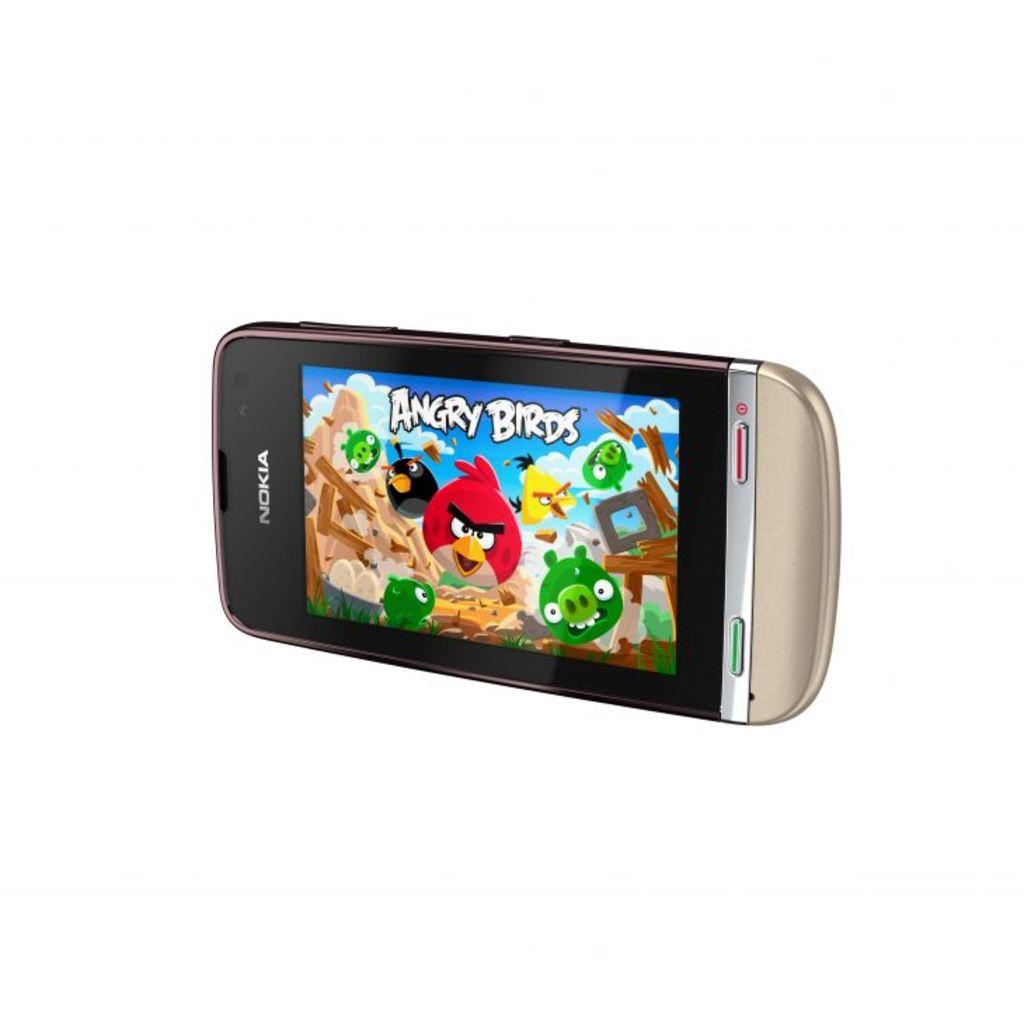What game is on the phone?
Provide a succinct answer. Angry birds. What kind of phone is this?
Your answer should be compact. Nokia. 